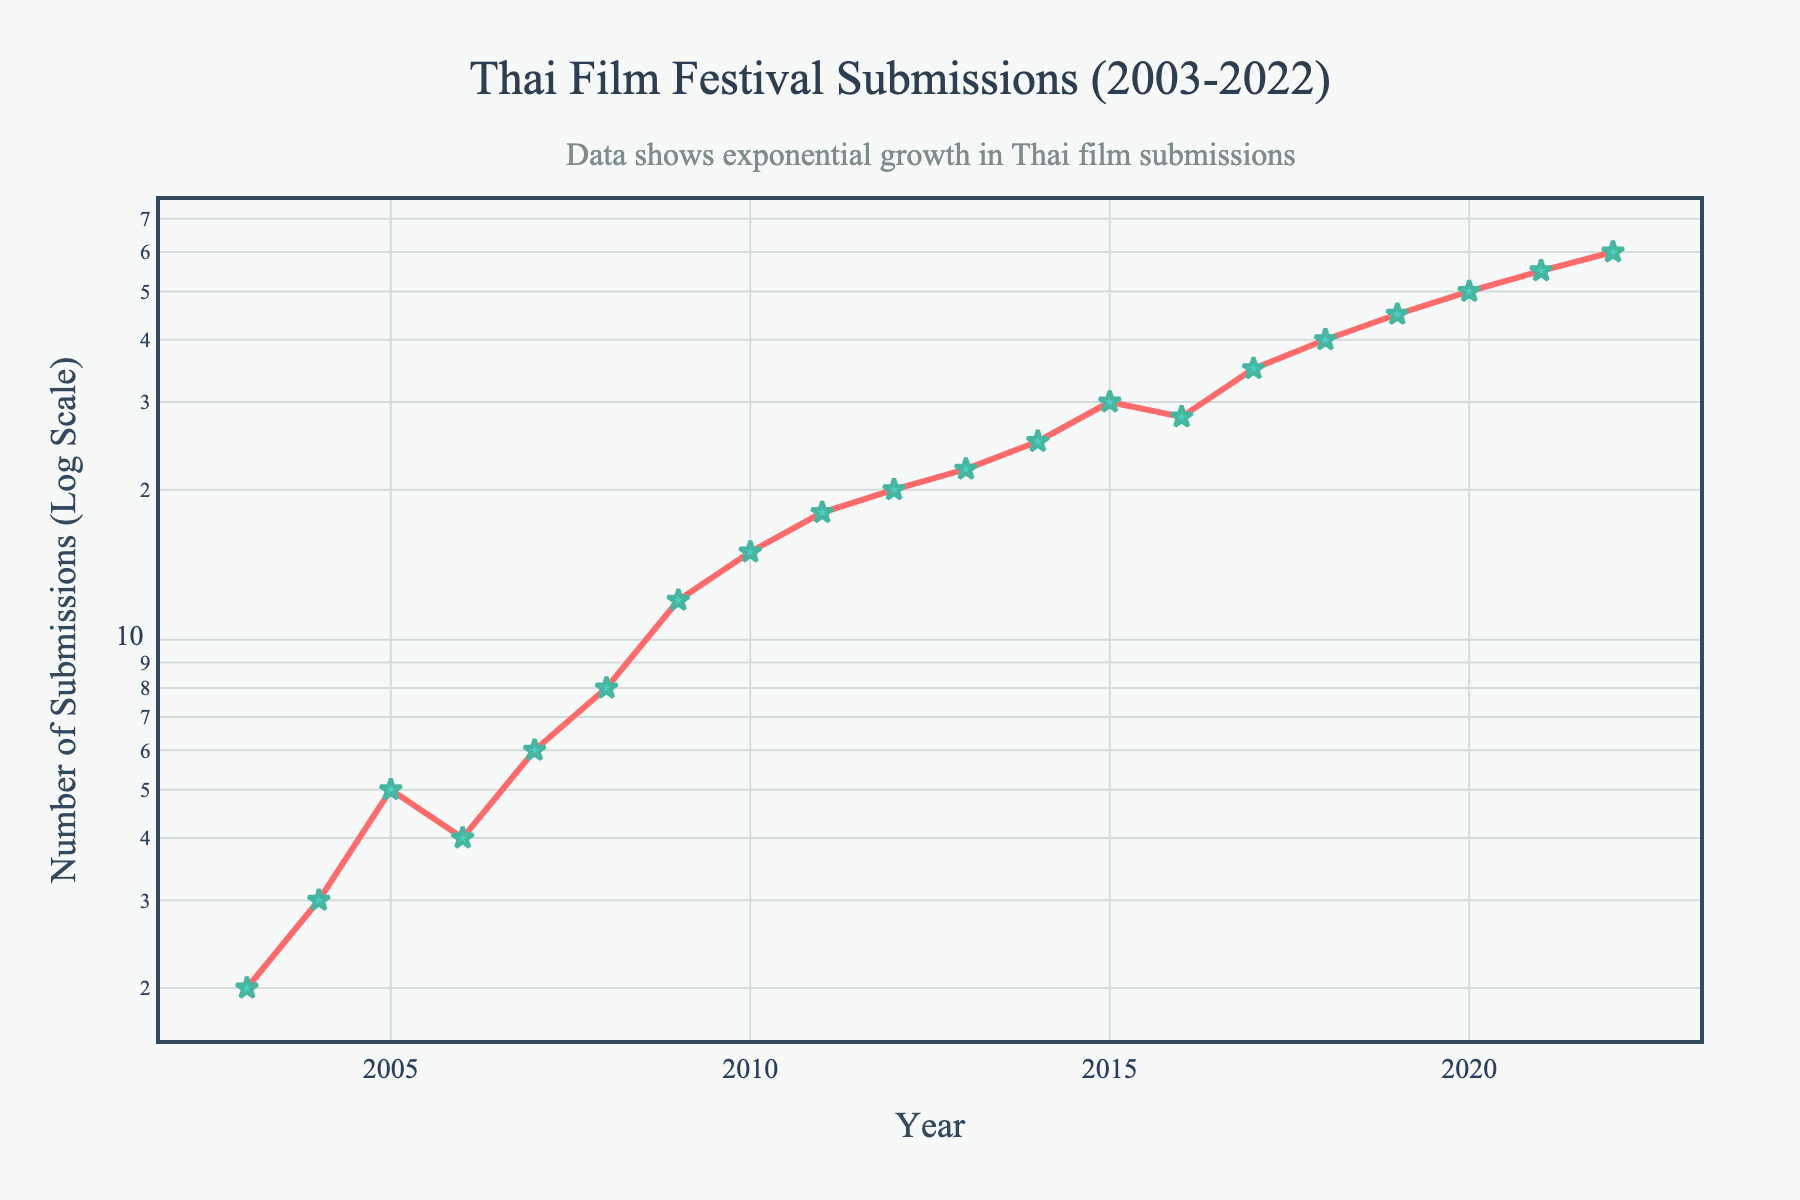What is the title of the plot? The title is a label at the top of the plot, it helps identify the content portrayed in the graph. The title is clearly stated in a larger font and usually centered.
Answer: Thai Film Festival Submissions (2003-2022) What is the y-axis title of the plot? The y-axis title is a label along the vertical axis of the plot. It indicates what the vertical axis represents.
Answer: Number of Submissions (Log Scale) When did the submissions start increasing exponentially? Observing the plot, the number of submissions grows steadily for the first few years but shows more rapid and consistent growth starting around 2008 onwards. This indicates an exponential growth pattern.
Answer: Around 2008 Which year had the highest number of submissions? By examining the peak of the data line, the year where this peak occurs marks the highest number of submissions.
Answer: 2022 What is the general trend in the number of submissions over the years? Observing the entire plot, there is a consistent increase in the number of submissions over the 20-year span, implying a positive trend in submissions.
Answer: Increasing trend What was the approximate number of submissions in 2010? Locate the data point for the year 2010 on the x-axis and read the corresponding value on the y-axis.
Answer: 15 How does the number of submissions in 2006 compare to 2015? By identifying the values at 2006 and 2015 from the plot, you can see that 2006 had 4 submissions while 2015 had 30, showing a significant increase.
Answer: 2015 had more submissions What is the average number of submissions from 2018 to 2022? Identify the number of submissions in each of these years (2018: 40, 2019: 45, 2020: 50, 2021: 55, 2022: 60), sum them (40 + 45 + 50 + 55 + 60 = 250) and divide by the number of years (5).
Answer: (40 + 45 + 50 + 55 + 60) / 5 = 50 By what factor did the submissions increase from 2009 to 2019? The number of submissions in 2009 was 12 and in 2019 it was 45. To find the factor increase, divide the 2019 value by the 2009 value: 45 / 12 ≈ 3.75.
Answer: Approximately 3.75 In which year did submissions first exceed 20? Locate the year on the plot where the number of submissions first crosses 20. This occurs in 2012.
Answer: 2012 